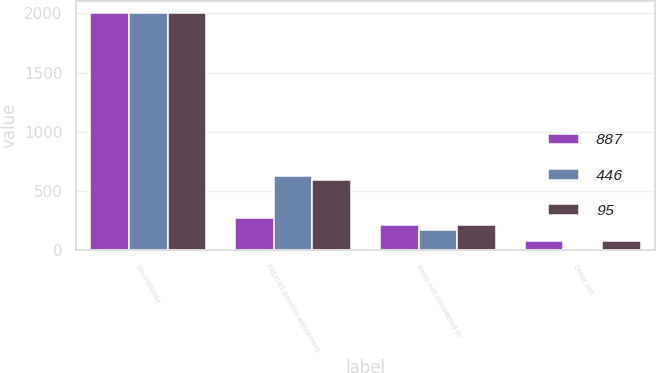Convert chart. <chart><loc_0><loc_0><loc_500><loc_500><stacked_bar_chart><ecel><fcel>(In millions)<fcel>FAS/CAS pension adjustment<fcel>Items not considered in<fcel>Other net<nl><fcel>887<fcel>2006<fcel>275<fcel>214<fcel>77<nl><fcel>446<fcel>2005<fcel>626<fcel>173<fcel>7<nl><fcel>95<fcel>2004<fcel>595<fcel>215<fcel>77<nl></chart> 